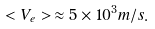<formula> <loc_0><loc_0><loc_500><loc_500>< V _ { e } > \, \approx 5 \times 1 0 ^ { 3 } m / s .</formula> 